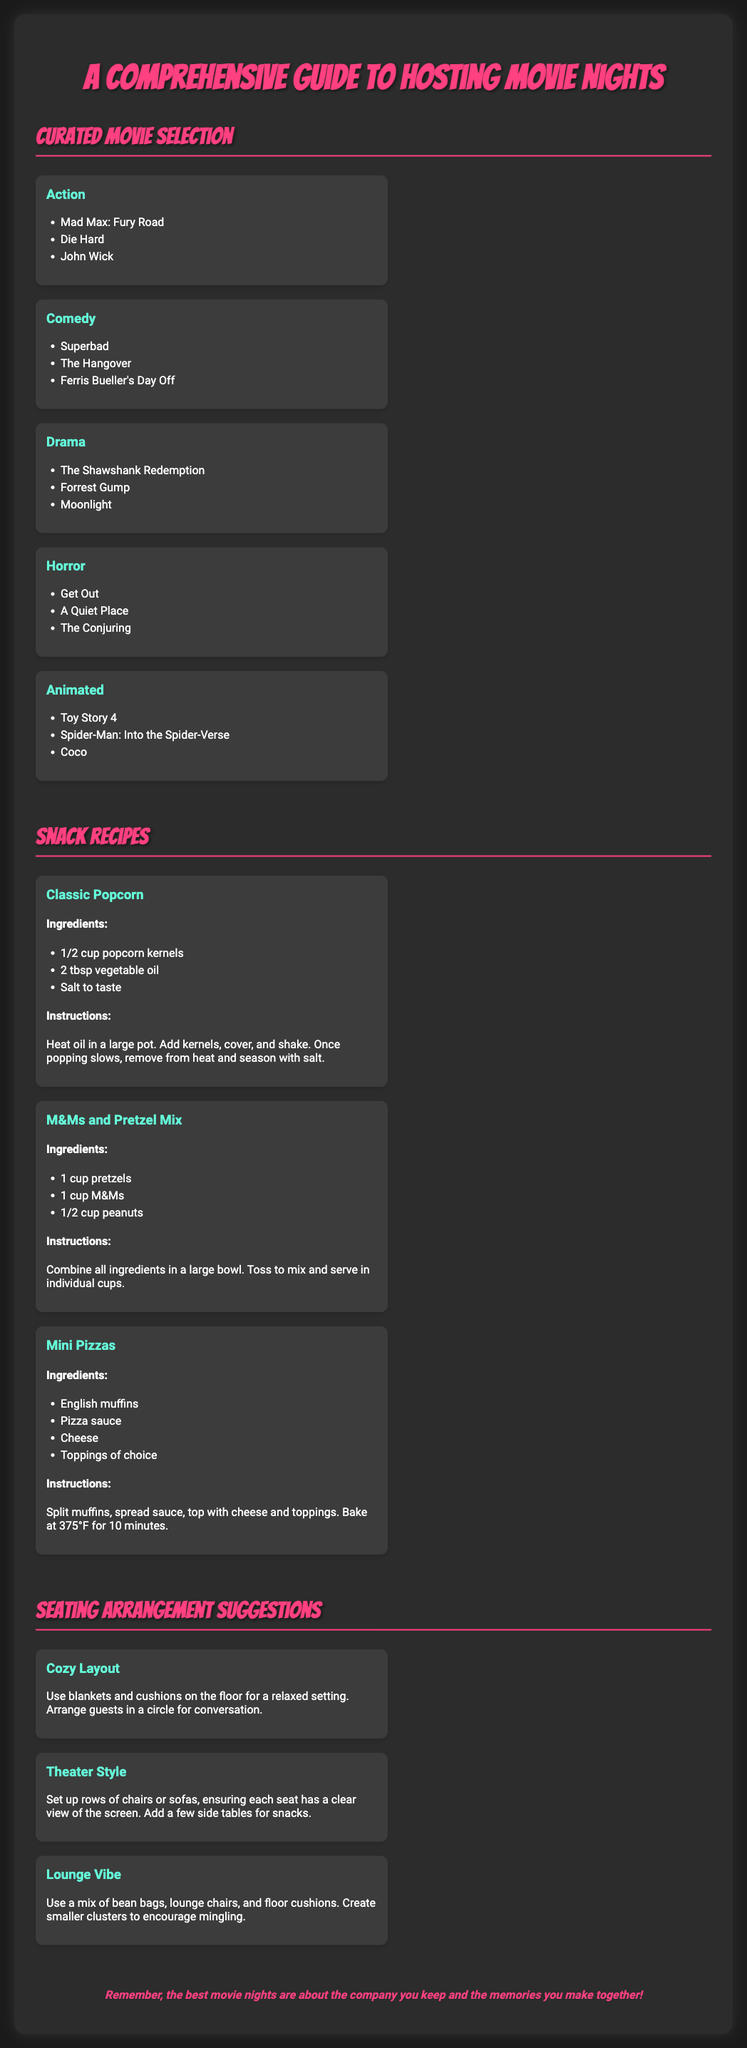What are the three genres listed under Action movies? The document lists three titles under the Action genre: Mad Max: Fury Road, Die Hard, and John Wick.
Answer: Mad Max: Fury Road, Die Hard, John Wick How many snack recipes are provided? The document contains three snack recipes: Classic Popcorn, M&Ms and Pretzel Mix, and Mini Pizzas.
Answer: 3 What is the main ingredient in Classic Popcorn? Classic Popcorn requires popcorn kernels, which is the primary ingredient listed under its recipe section.
Answer: Popcorn kernels Which seating arrangement encourages mingling? The document describes the Lounge Vibe as utilizing a mix of seating to create clusters that are conducive to conversation and mingling.
Answer: Lounge Vibe Which movie is mentioned in the Comedy genre? The Comedy genre includes three titles, one of which is The Hangover.
Answer: The Hangover How many seating arrangement styles are suggested? There are three seating arrangement styles provided in the document: Cozy Layout, Theater Style, and Lounge Vibe.
Answer: 3 What is the cooking temperature for Mini Pizzas? The document states that Mini Pizzas should be baked at a temperature of 375°F.
Answer: 375°F What is emphasized as most important in movie nights? The closing note of the document emphasizes the importance of the company and memories during movie nights.
Answer: Company and memories 